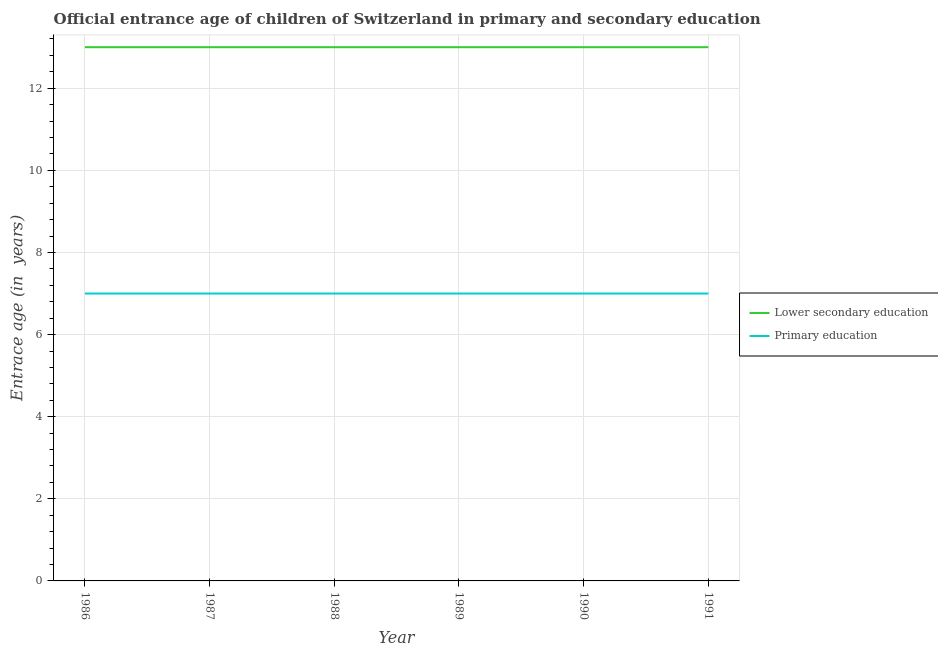How many different coloured lines are there?
Keep it short and to the point. 2. Does the line corresponding to entrance age of children in lower secondary education intersect with the line corresponding to entrance age of chiildren in primary education?
Ensure brevity in your answer.  No. Is the number of lines equal to the number of legend labels?
Provide a succinct answer. Yes. What is the entrance age of children in lower secondary education in 1990?
Give a very brief answer. 13. Across all years, what is the maximum entrance age of children in lower secondary education?
Offer a terse response. 13. Across all years, what is the minimum entrance age of chiildren in primary education?
Give a very brief answer. 7. In which year was the entrance age of chiildren in primary education maximum?
Your response must be concise. 1986. What is the total entrance age of children in lower secondary education in the graph?
Keep it short and to the point. 78. What is the difference between the entrance age of chiildren in primary education in 1986 and the entrance age of children in lower secondary education in 1987?
Keep it short and to the point. -6. What is the average entrance age of children in lower secondary education per year?
Provide a succinct answer. 13. Is the entrance age of children in lower secondary education in 1986 less than that in 1990?
Make the answer very short. No. What is the difference between the highest and the lowest entrance age of children in lower secondary education?
Provide a short and direct response. 0. In how many years, is the entrance age of children in lower secondary education greater than the average entrance age of children in lower secondary education taken over all years?
Provide a succinct answer. 0. Is the sum of the entrance age of children in lower secondary education in 1987 and 1990 greater than the maximum entrance age of chiildren in primary education across all years?
Give a very brief answer. Yes. Does the entrance age of children in lower secondary education monotonically increase over the years?
Your response must be concise. No. Is the entrance age of children in lower secondary education strictly greater than the entrance age of chiildren in primary education over the years?
Provide a short and direct response. Yes. How many years are there in the graph?
Give a very brief answer. 6. What is the difference between two consecutive major ticks on the Y-axis?
Give a very brief answer. 2. Where does the legend appear in the graph?
Your response must be concise. Center right. How many legend labels are there?
Offer a terse response. 2. What is the title of the graph?
Offer a terse response. Official entrance age of children of Switzerland in primary and secondary education. Does "Lower secondary rate" appear as one of the legend labels in the graph?
Your answer should be compact. No. What is the label or title of the Y-axis?
Ensure brevity in your answer.  Entrace age (in  years). What is the Entrace age (in  years) in Lower secondary education in 1986?
Provide a short and direct response. 13. What is the Entrace age (in  years) of Primary education in 1987?
Offer a very short reply. 7. What is the Entrace age (in  years) in Lower secondary education in 1988?
Offer a very short reply. 13. What is the Entrace age (in  years) in Lower secondary education in 1989?
Offer a very short reply. 13. What is the Entrace age (in  years) of Lower secondary education in 1990?
Offer a very short reply. 13. What is the Entrace age (in  years) in Primary education in 1990?
Your answer should be very brief. 7. What is the Entrace age (in  years) in Lower secondary education in 1991?
Make the answer very short. 13. Across all years, what is the maximum Entrace age (in  years) in Lower secondary education?
Provide a short and direct response. 13. Across all years, what is the minimum Entrace age (in  years) in Lower secondary education?
Give a very brief answer. 13. Across all years, what is the minimum Entrace age (in  years) of Primary education?
Your answer should be compact. 7. What is the total Entrace age (in  years) of Primary education in the graph?
Offer a very short reply. 42. What is the difference between the Entrace age (in  years) of Lower secondary education in 1986 and that in 1989?
Offer a terse response. 0. What is the difference between the Entrace age (in  years) of Lower secondary education in 1986 and that in 1990?
Your response must be concise. 0. What is the difference between the Entrace age (in  years) in Lower secondary education in 1986 and that in 1991?
Provide a succinct answer. 0. What is the difference between the Entrace age (in  years) in Primary education in 1986 and that in 1991?
Offer a terse response. 0. What is the difference between the Entrace age (in  years) in Lower secondary education in 1987 and that in 1989?
Provide a short and direct response. 0. What is the difference between the Entrace age (in  years) of Lower secondary education in 1987 and that in 1990?
Give a very brief answer. 0. What is the difference between the Entrace age (in  years) of Lower secondary education in 1987 and that in 1991?
Give a very brief answer. 0. What is the difference between the Entrace age (in  years) of Primary education in 1987 and that in 1991?
Give a very brief answer. 0. What is the difference between the Entrace age (in  years) of Lower secondary education in 1988 and that in 1990?
Give a very brief answer. 0. What is the difference between the Entrace age (in  years) in Lower secondary education in 1988 and that in 1991?
Provide a short and direct response. 0. What is the difference between the Entrace age (in  years) in Primary education in 1988 and that in 1991?
Provide a short and direct response. 0. What is the difference between the Entrace age (in  years) of Lower secondary education in 1989 and that in 1990?
Your response must be concise. 0. What is the difference between the Entrace age (in  years) in Primary education in 1989 and that in 1990?
Provide a succinct answer. 0. What is the difference between the Entrace age (in  years) in Primary education in 1990 and that in 1991?
Your response must be concise. 0. What is the difference between the Entrace age (in  years) of Lower secondary education in 1986 and the Entrace age (in  years) of Primary education in 1988?
Your response must be concise. 6. What is the difference between the Entrace age (in  years) of Lower secondary education in 1987 and the Entrace age (in  years) of Primary education in 1988?
Give a very brief answer. 6. What is the difference between the Entrace age (in  years) of Lower secondary education in 1987 and the Entrace age (in  years) of Primary education in 1989?
Your response must be concise. 6. What is the difference between the Entrace age (in  years) in Lower secondary education in 1988 and the Entrace age (in  years) in Primary education in 1989?
Ensure brevity in your answer.  6. What is the difference between the Entrace age (in  years) in Lower secondary education in 1988 and the Entrace age (in  years) in Primary education in 1990?
Give a very brief answer. 6. What is the difference between the Entrace age (in  years) of Lower secondary education in 1989 and the Entrace age (in  years) of Primary education in 1991?
Your answer should be compact. 6. What is the difference between the Entrace age (in  years) in Lower secondary education in 1990 and the Entrace age (in  years) in Primary education in 1991?
Offer a very short reply. 6. What is the average Entrace age (in  years) in Lower secondary education per year?
Offer a very short reply. 13. In the year 1987, what is the difference between the Entrace age (in  years) in Lower secondary education and Entrace age (in  years) in Primary education?
Your answer should be very brief. 6. In the year 1990, what is the difference between the Entrace age (in  years) of Lower secondary education and Entrace age (in  years) of Primary education?
Your answer should be compact. 6. What is the ratio of the Entrace age (in  years) in Lower secondary education in 1986 to that in 1988?
Give a very brief answer. 1. What is the ratio of the Entrace age (in  years) of Lower secondary education in 1986 to that in 1989?
Offer a terse response. 1. What is the ratio of the Entrace age (in  years) of Primary education in 1986 to that in 1989?
Ensure brevity in your answer.  1. What is the ratio of the Entrace age (in  years) in Lower secondary education in 1987 to that in 1989?
Give a very brief answer. 1. What is the ratio of the Entrace age (in  years) of Primary education in 1987 to that in 1989?
Ensure brevity in your answer.  1. What is the ratio of the Entrace age (in  years) in Lower secondary education in 1987 to that in 1990?
Make the answer very short. 1. What is the ratio of the Entrace age (in  years) in Primary education in 1987 to that in 1990?
Offer a terse response. 1. What is the ratio of the Entrace age (in  years) in Lower secondary education in 1988 to that in 1989?
Keep it short and to the point. 1. What is the ratio of the Entrace age (in  years) in Lower secondary education in 1988 to that in 1990?
Provide a succinct answer. 1. What is the ratio of the Entrace age (in  years) in Primary education in 1988 to that in 1990?
Provide a short and direct response. 1. What is the ratio of the Entrace age (in  years) of Primary education in 1988 to that in 1991?
Your answer should be compact. 1. What is the ratio of the Entrace age (in  years) in Primary education in 1989 to that in 1990?
Keep it short and to the point. 1. What is the difference between the highest and the second highest Entrace age (in  years) of Primary education?
Your answer should be very brief. 0. What is the difference between the highest and the lowest Entrace age (in  years) in Lower secondary education?
Keep it short and to the point. 0. 